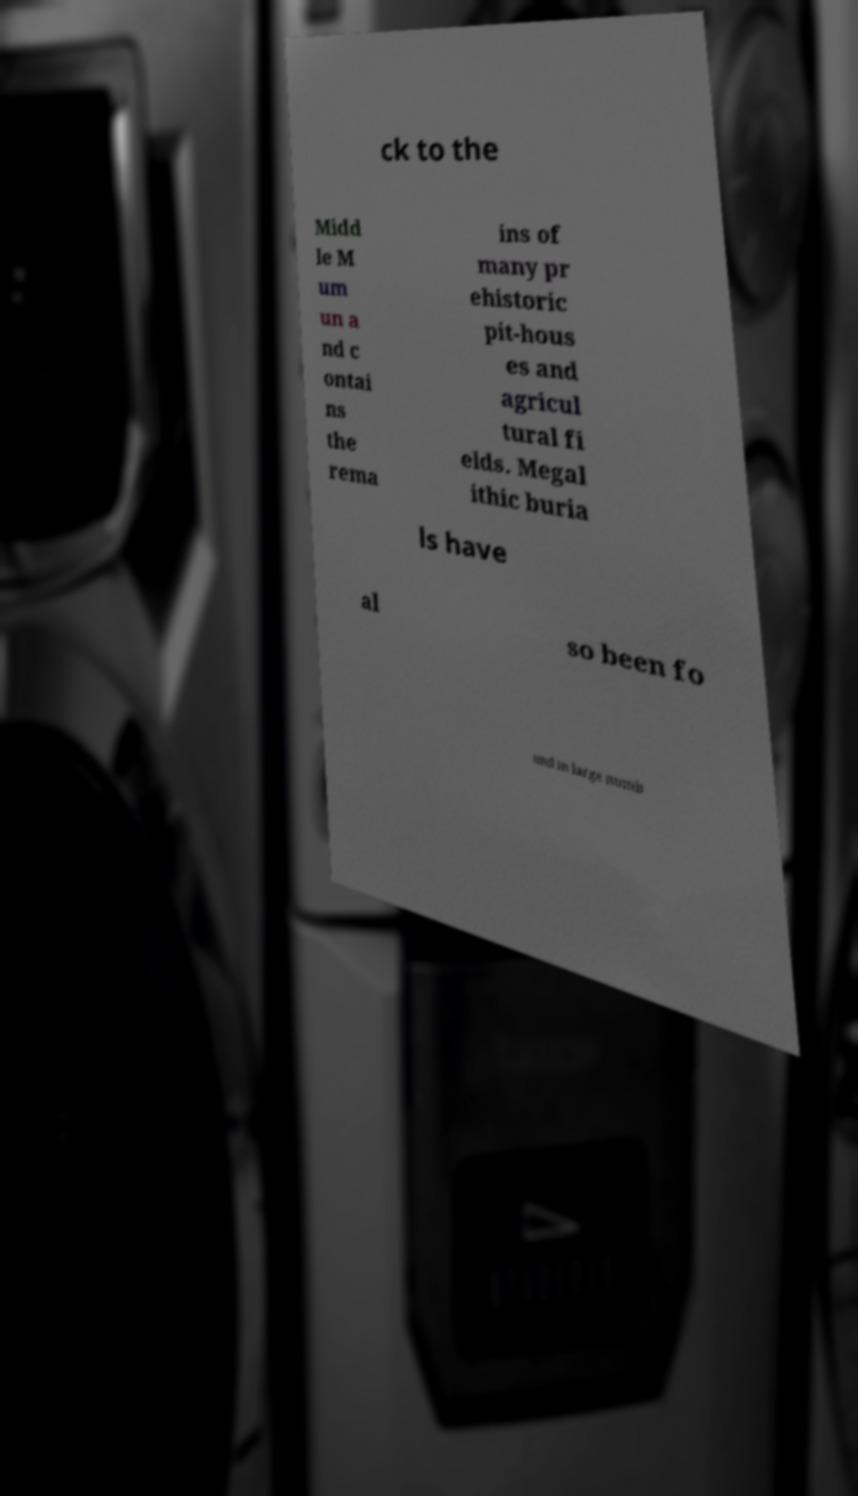There's text embedded in this image that I need extracted. Can you transcribe it verbatim? ck to the Midd le M um un a nd c ontai ns the rema ins of many pr ehistoric pit-hous es and agricul tural fi elds. Megal ithic buria ls have al so been fo und in large numb 